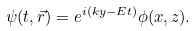<formula> <loc_0><loc_0><loc_500><loc_500>\psi ( t , \vec { r } ) = e ^ { i ( k y - E t ) } \phi ( x , z ) .</formula> 